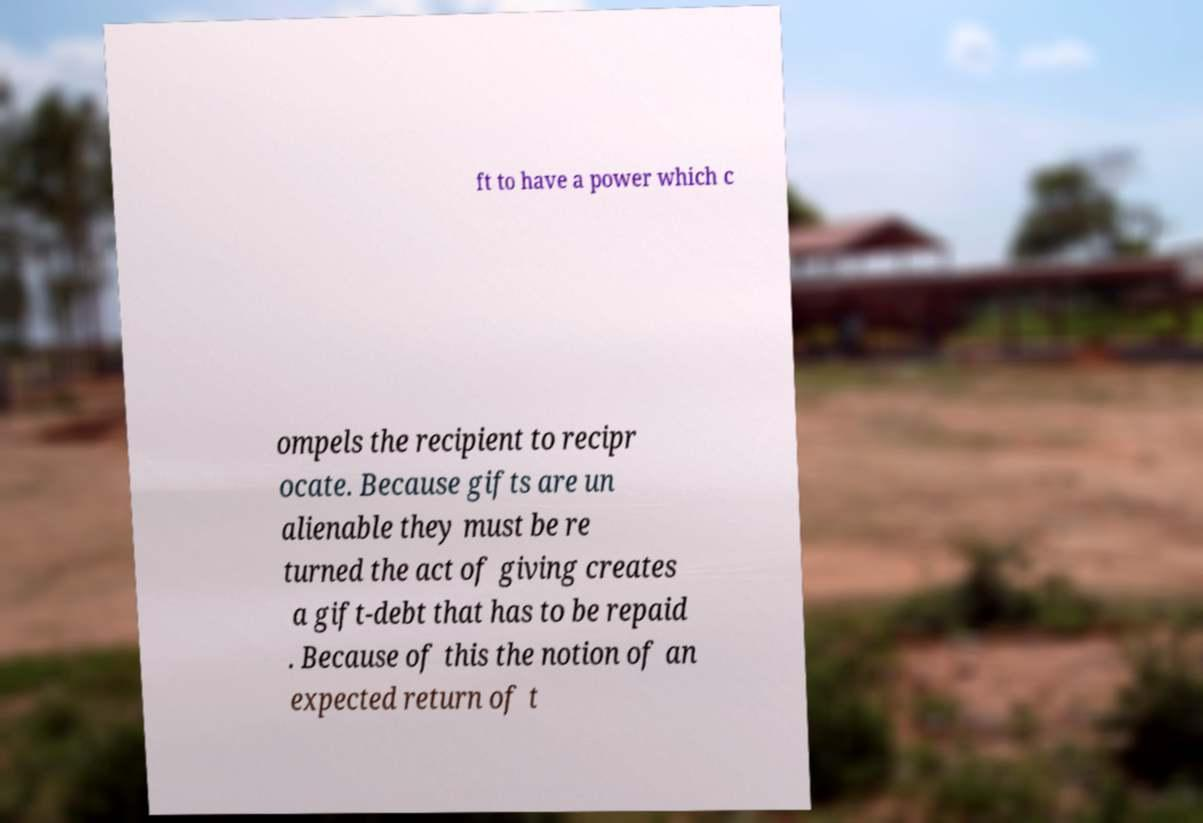Can you accurately transcribe the text from the provided image for me? ft to have a power which c ompels the recipient to recipr ocate. Because gifts are un alienable they must be re turned the act of giving creates a gift-debt that has to be repaid . Because of this the notion of an expected return of t 